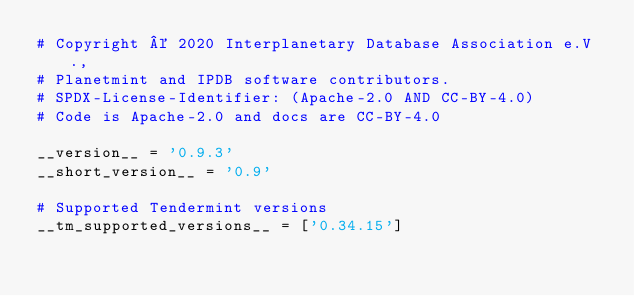Convert code to text. <code><loc_0><loc_0><loc_500><loc_500><_Python_># Copyright © 2020 Interplanetary Database Association e.V.,
# Planetmint and IPDB software contributors.
# SPDX-License-Identifier: (Apache-2.0 AND CC-BY-4.0)
# Code is Apache-2.0 and docs are CC-BY-4.0

__version__ = '0.9.3'
__short_version__ = '0.9'

# Supported Tendermint versions
__tm_supported_versions__ = ['0.34.15']
</code> 